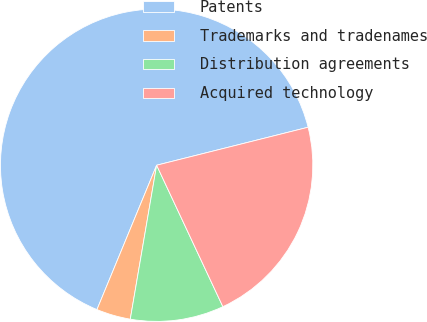<chart> <loc_0><loc_0><loc_500><loc_500><pie_chart><fcel>Patents<fcel>Trademarks and tradenames<fcel>Distribution agreements<fcel>Acquired technology<nl><fcel>64.85%<fcel>3.54%<fcel>9.67%<fcel>21.94%<nl></chart> 